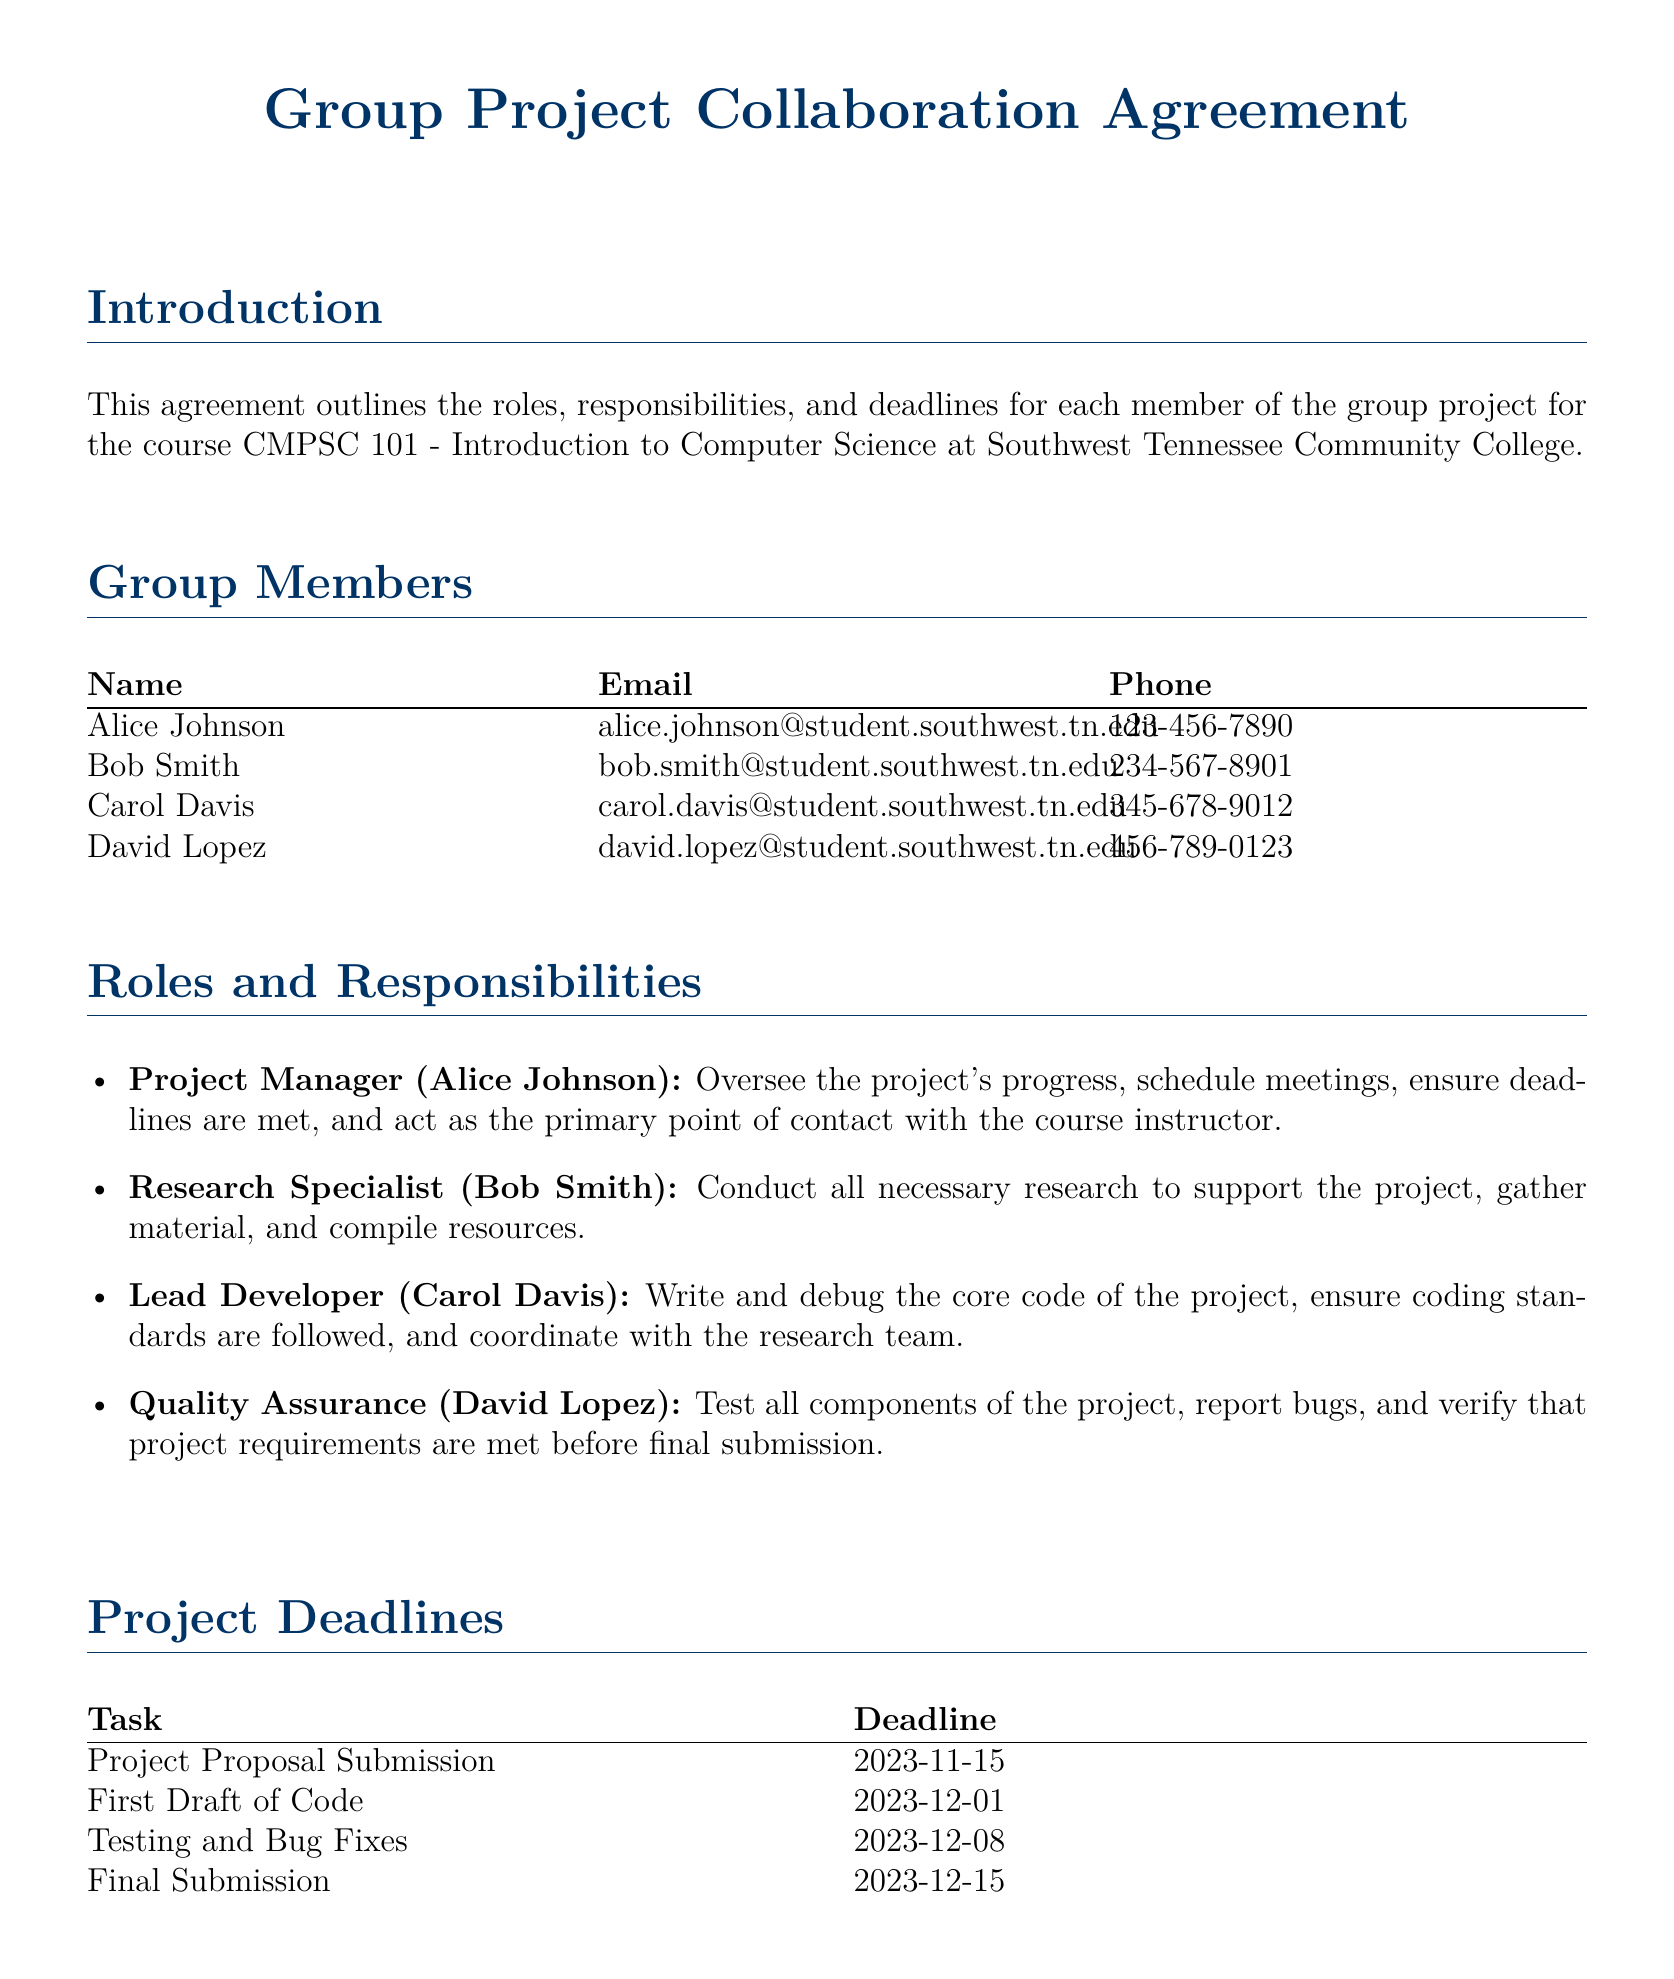What is the course name? The course name is specified as CMPSC 101 - Introduction to Computer Science.
Answer: CMPSC 101 - Introduction to Computer Science Who is the Project Manager? The document lists Alice Johnson as the Project Manager responsible for overseeing the project's progress.
Answer: Alice Johnson What is the deadline for the Project Proposal Submission? The deadline for the Project Proposal Submission is stated in the Project Deadlines section as 2023-11-15.
Answer: 2023-11-15 How often will review meetings occur? The Communication Plan indicates that weekly review meetings will be held every Monday at 5:00 PM.
Answer: Every Monday What is the role of David Lopez? David Lopez is responsible for testing all components of the project as the Quality Assurance member.
Answer: Quality Assurance If a conflict arises, who will mediate the issue? The document states that Professor Susan Miller will mediate unresolved conflicts.
Answer: Professor Susan Miller What platform is used for daily updates? The Communication Plan specifies that Slack is the platform for daily updates among team members.
Answer: Slack When is the Final Submission deadline? The Final Submission deadline is mentioned in the Project Deadlines as 2023-12-15.
Answer: 2023-12-15 What is Bob Smith's email address? The document provides Bob Smith's contact information, including his email address.
Answer: bob.smith@student.southwest.tn.edu 